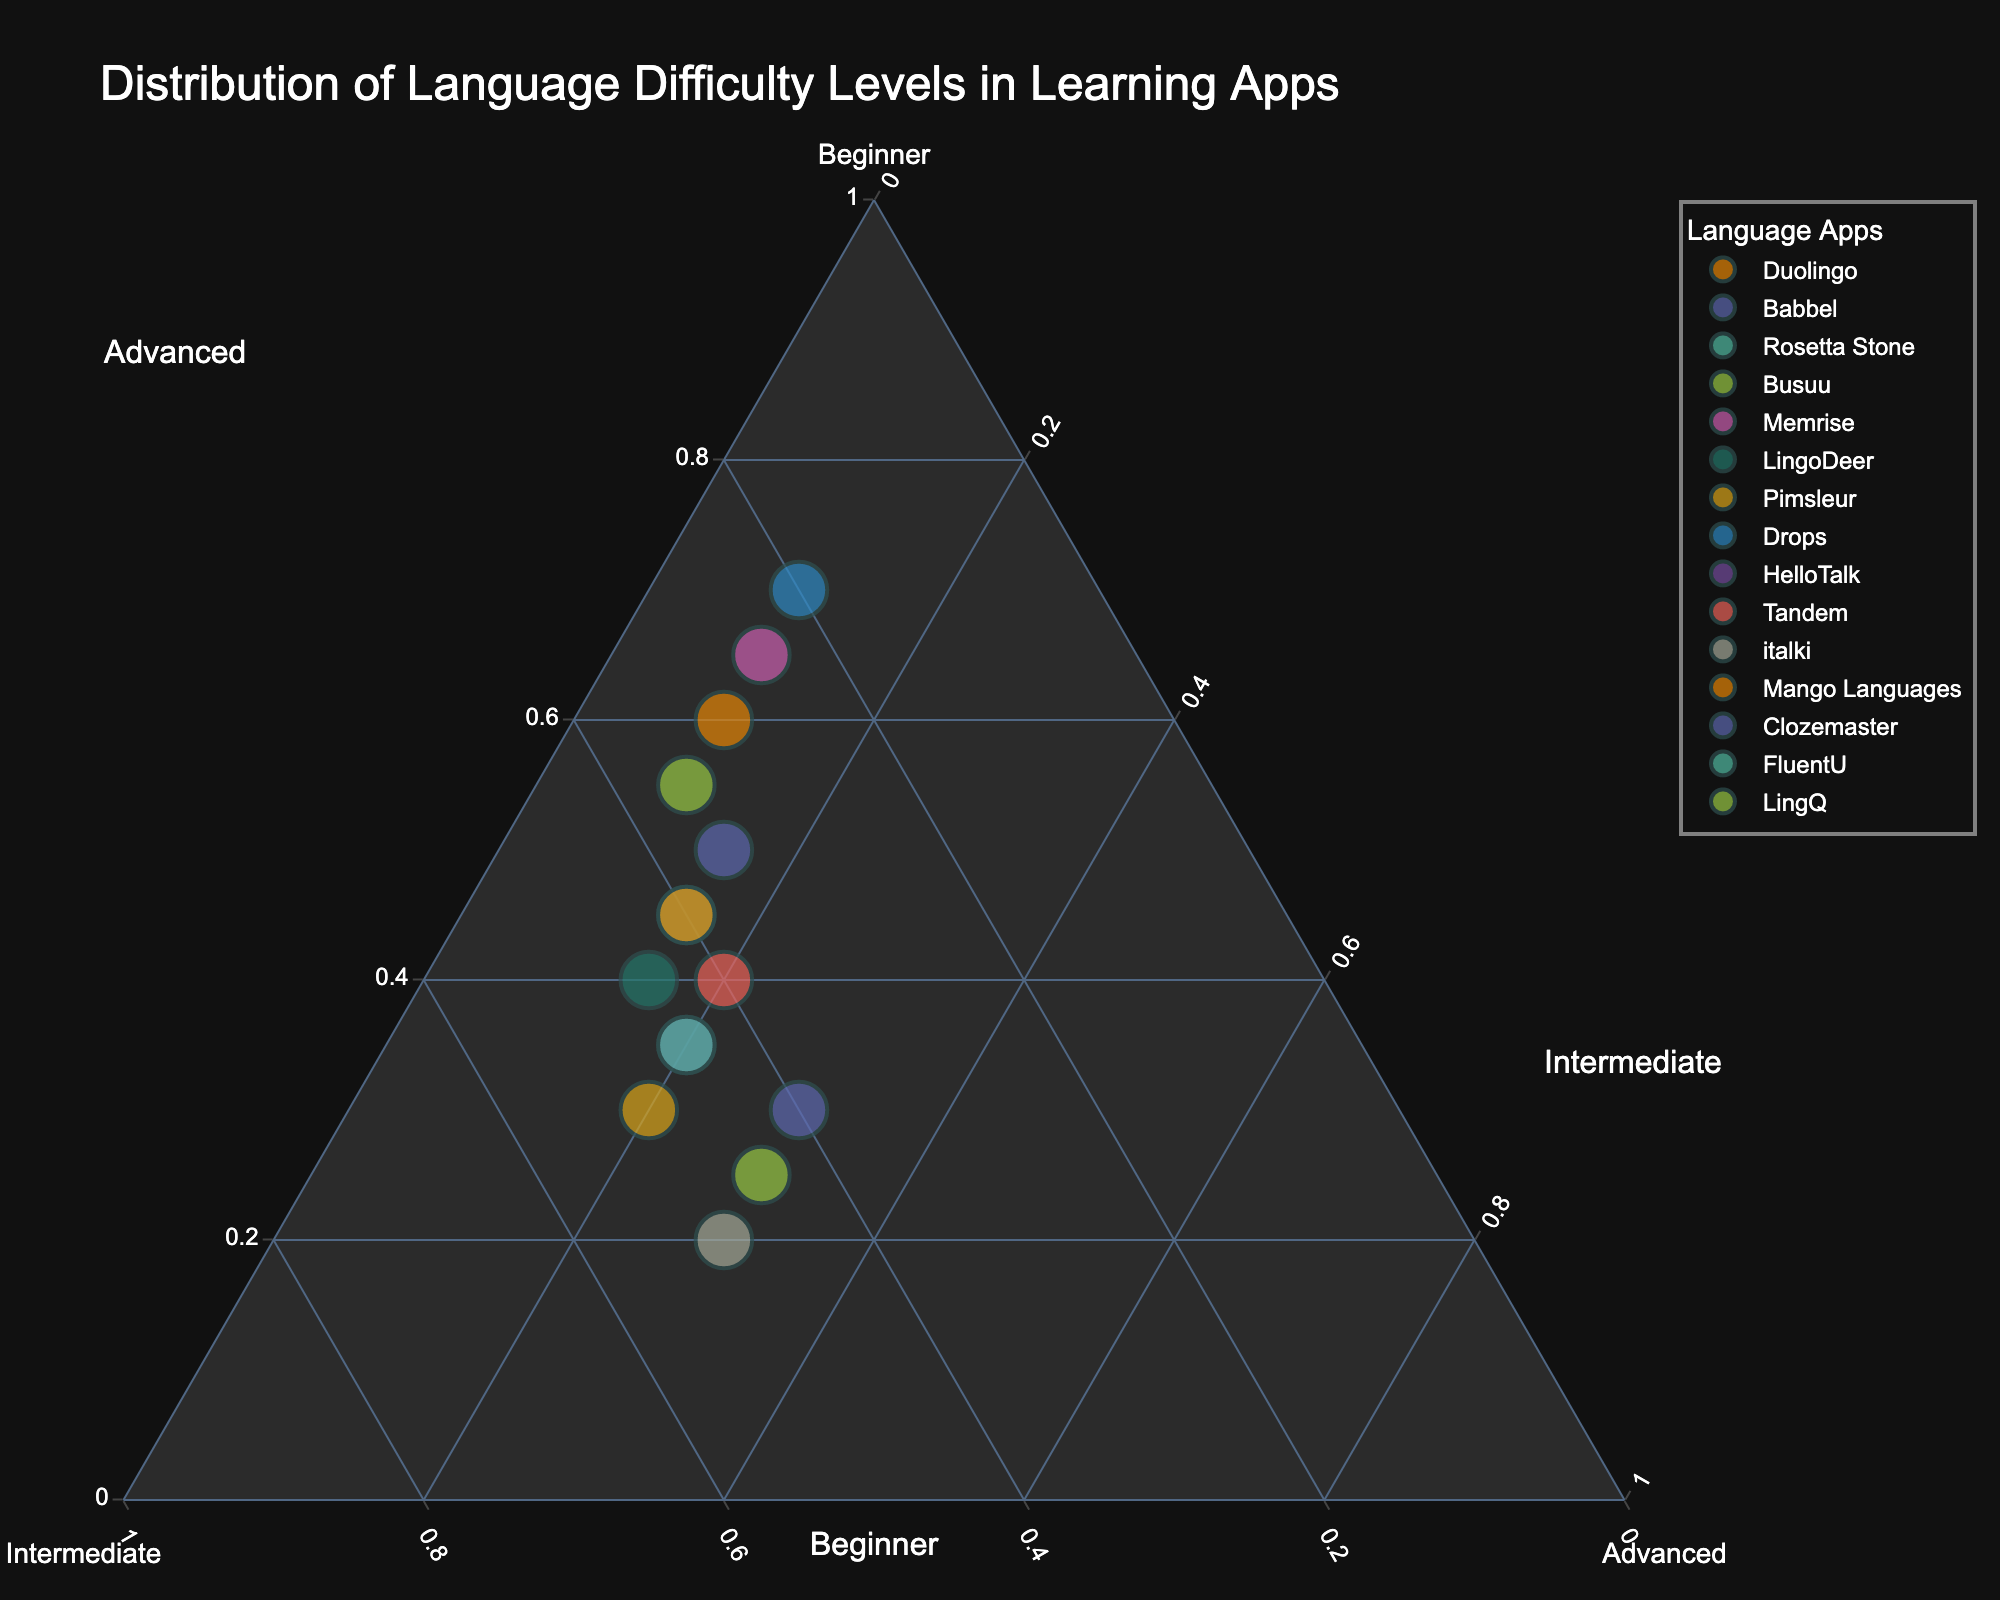What is the title of the plot? The title is typically located at the top center of the figure and is designed to provide a concise description of what the figure represents.
Answer: Distribution of Language Difficulty Levels in Learning Apps How many language learning apps contain more beginner content than intermediate content? By visually inspecting the plot, we count the number of points where the percentage of beginner content is higher than that of intermediate content.
Answer: 9 Which app has the highest proportion of advanced content? The app with the highest proportion of advanced content will be represented by the point closest to the "Advanced" corner of the ternary plot.
Answer: italki Which app shows an equal proportion of intermediate and advanced content? Look for a point that lies on the line where the intermediate and advanced axes represent the same value.
Answer: Clozemaster What is the proportion of beginner content in Drops? Locate Drops in the plot and read the proportion of beginner content from its position relative to the "Beginner" corner.
Answer: 70% Which two apps have the closest balance between beginner, intermediate, and advanced content? Find the points that are closest to the center of the plot, indicating nearly equal proportions of beginner, intermediate, and advanced content.
Answer: Tandem and Mango Languages Which app has the highest proportion of beginner content? This app will be represented by the point closest to the "Beginner" corner of the ternary plot.
Answer: Drops Among the apps with higher intermediate content than beginner content, which one has the highest advanced content percentage? First identify the apps with a greater intermediate than beginner content and then among those, find the one closest to the "Advanced" axis.
Answer: LingQ 